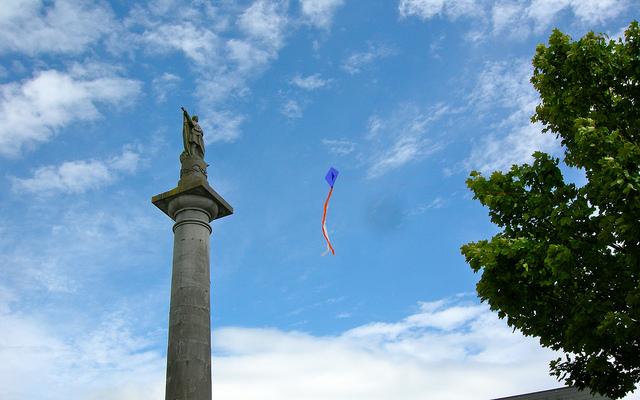Are there lots of clouds in the sky?
Give a very brief answer. Yes. What is at the top of the column?
Write a very short answer. Statue. What is flying in the sky?
Short answer required. Kite. Was this picture taken around lunchtime?
Write a very short answer. Yes. 